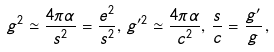Convert formula to latex. <formula><loc_0><loc_0><loc_500><loc_500>g ^ { 2 } \simeq \frac { 4 \pi \alpha } { s ^ { 2 } } = \frac { e ^ { 2 } } { s ^ { 2 } } , \, g ^ { \prime 2 } \simeq \frac { 4 \pi \alpha } { c ^ { 2 } } , \, \frac { s } { c } = \frac { g ^ { \prime } } { g } \, ,</formula> 